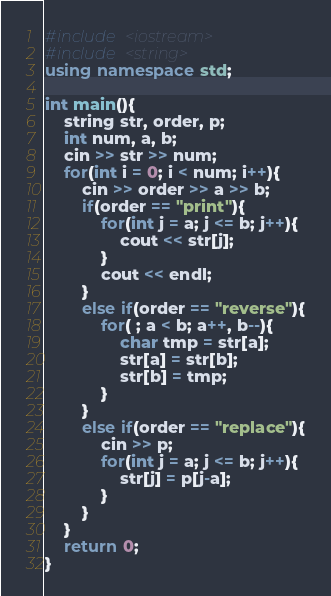Convert code to text. <code><loc_0><loc_0><loc_500><loc_500><_C++_>#include <iostream>
#include <string>
using namespace std;

int main(){
	string str, order, p;
	int num, a, b;
	cin >> str >> num;
	for(int i = 0; i < num; i++){
		cin >> order >> a >> b;
		if(order == "print"){
			for(int j = a; j <= b; j++){
				cout << str[j];
			}
			cout << endl;
		}
		else if(order == "reverse"){
			for( ; a < b; a++, b--){
				char tmp = str[a];
				str[a] = str[b];
				str[b] = tmp;
			}
		}
		else if(order == "replace"){
			cin >> p;
			for(int j = a; j <= b; j++){
				str[j] = p[j-a];
			}
		}
	}
	return 0;
}
</code> 